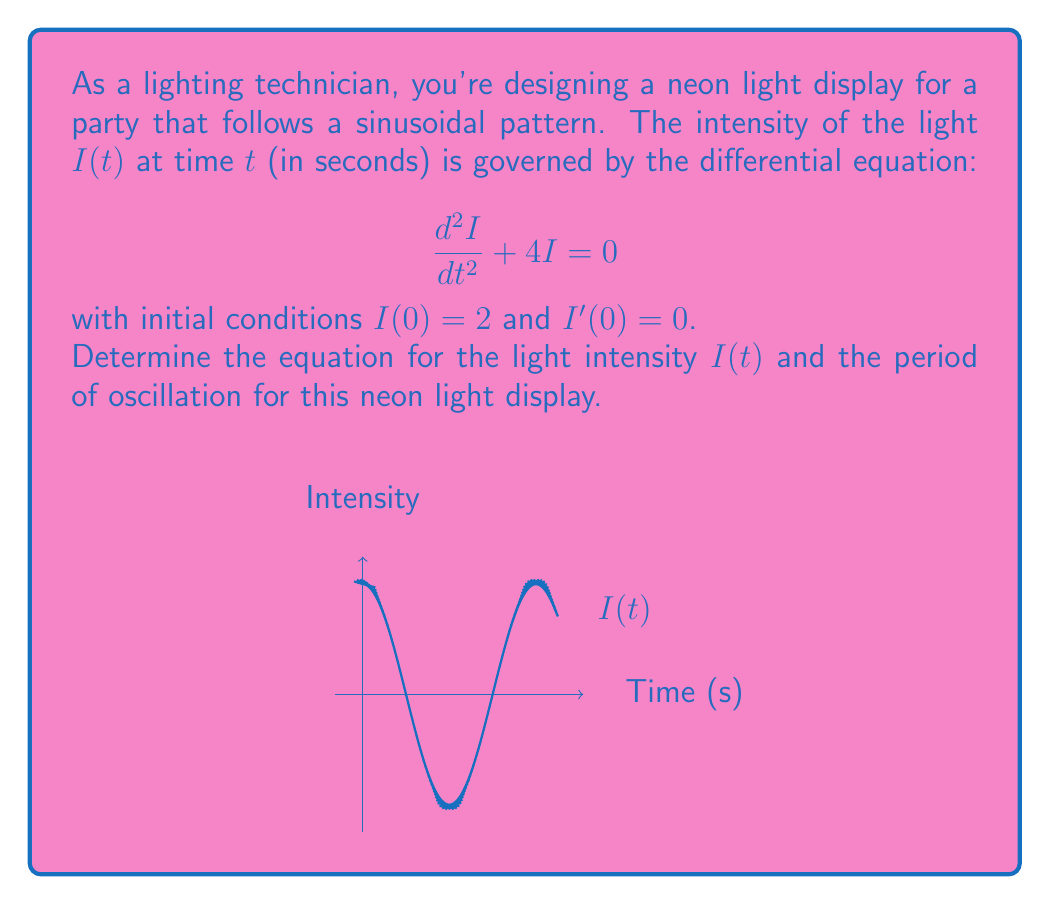Could you help me with this problem? Let's solve this step-by-step:

1) The given differential equation is in the form of a simple harmonic oscillator:
   $$\frac{d^2I}{dt^2} + \omega^2I = 0$$
   where $\omega^2 = 4$, so $\omega = 2$.

2) The general solution for this equation is:
   $$I(t) = A\cos(2t) + B\sin(2t)$$

3) To find $A$ and $B$, we use the initial conditions:
   
   For $I(0) = 2$:
   $$I(0) = A\cos(0) + B\sin(0) = A = 2$$

   For $I'(0) = 0$:
   $$I'(t) = -2A\sin(2t) + 2B\cos(2t)$$
   $$I'(0) = 2B = 0$$
   $$B = 0$$

4) Therefore, the specific solution is:
   $$I(t) = 2\cos(2t)$$

5) To find the period $T$, we use the formula $T = \frac{2\pi}{\omega}$:
   $$T = \frac{2\pi}{2} = \pi$$

Thus, the light intensity oscillates according to $I(t) = 2\cos(2t)$ with a period of $\pi$ seconds.
Answer: $I(t) = 2\cos(2t)$, Period = $\pi$ seconds 